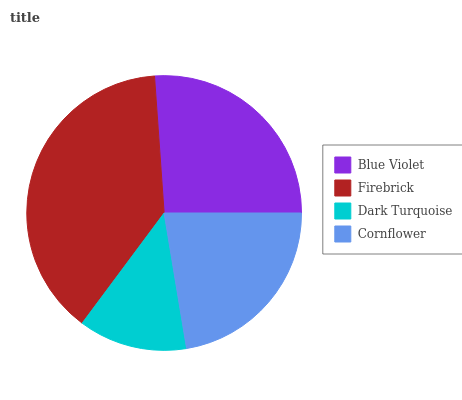Is Dark Turquoise the minimum?
Answer yes or no. Yes. Is Firebrick the maximum?
Answer yes or no. Yes. Is Firebrick the minimum?
Answer yes or no. No. Is Dark Turquoise the maximum?
Answer yes or no. No. Is Firebrick greater than Dark Turquoise?
Answer yes or no. Yes. Is Dark Turquoise less than Firebrick?
Answer yes or no. Yes. Is Dark Turquoise greater than Firebrick?
Answer yes or no. No. Is Firebrick less than Dark Turquoise?
Answer yes or no. No. Is Blue Violet the high median?
Answer yes or no. Yes. Is Cornflower the low median?
Answer yes or no. Yes. Is Cornflower the high median?
Answer yes or no. No. Is Dark Turquoise the low median?
Answer yes or no. No. 